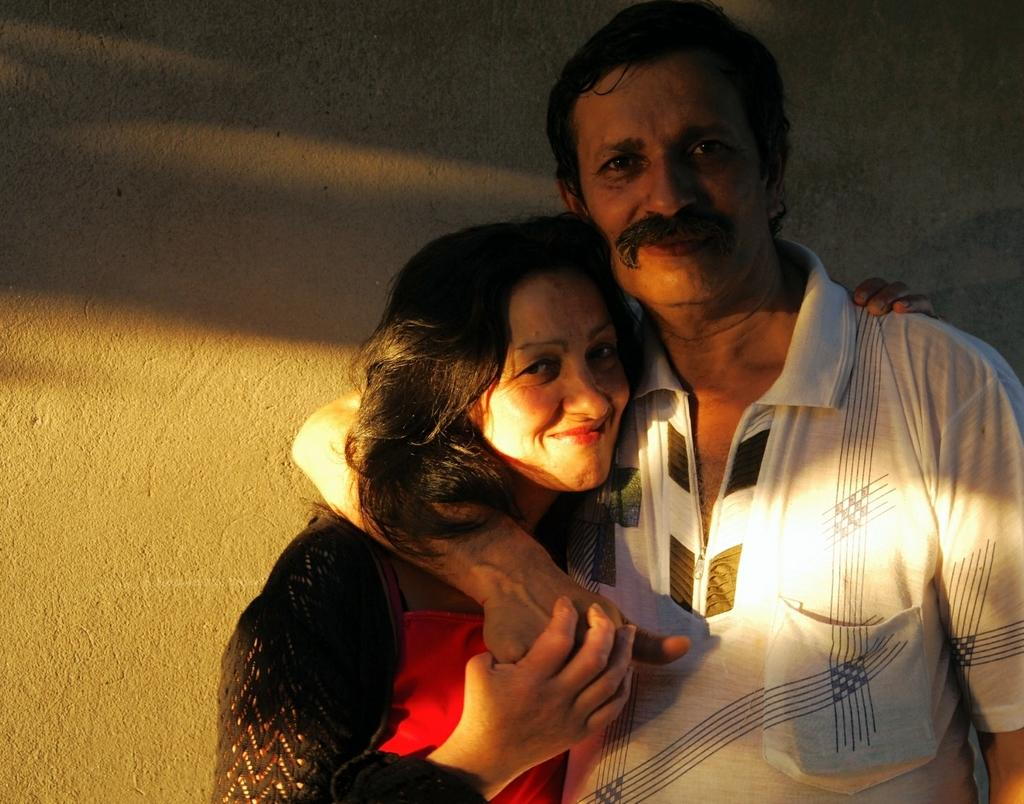What is the main subject in the foreground of the image? There is a man in the foreground of the image. What is the man doing in the image? The man has his hand over a woman's shoulder. What can be seen in the background of the image? There is a wall in the background of the image. What type of jam is being spread on the trees in the image? There are no trees or jam present in the image. How does the soap help the man in the image? There is no soap present in the image, so it cannot help the man. 